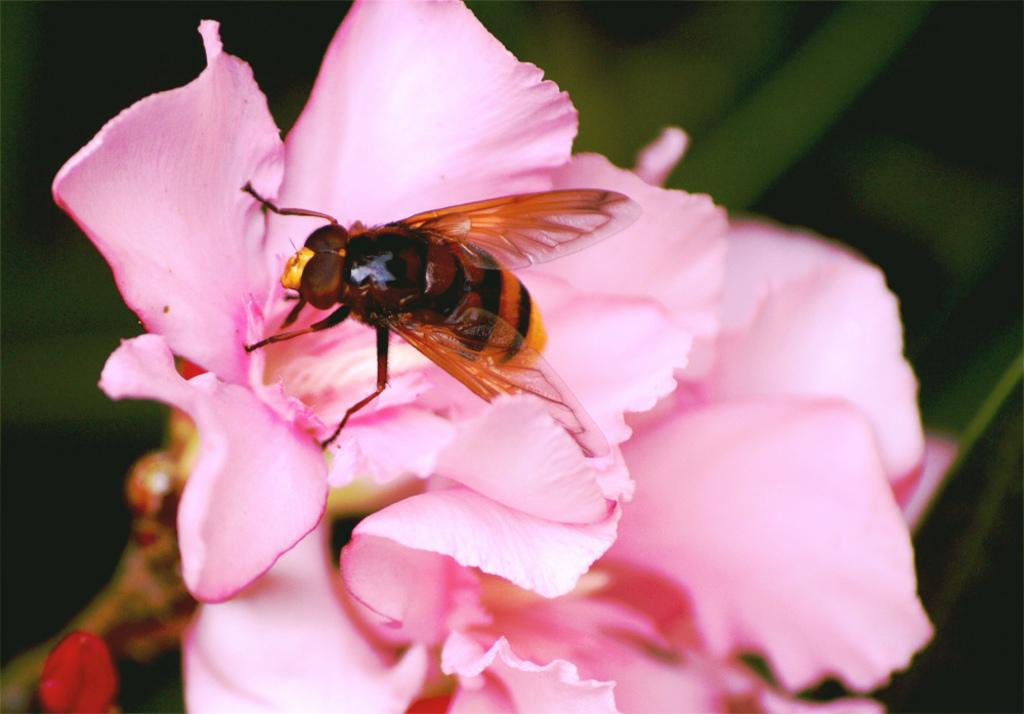What is located in the center of the image? There are flowers in the center of the image. Can you describe any other elements present on the flowers? Yes, there is an insect on the flowers. How many girls are sitting at the table in the image? There is no table or girls present in the image; it features flowers with an insect on them. What type of snakes can be seen slithering around the flowers in the image? There are no snakes present in the image; it only features flowers and an insect. 